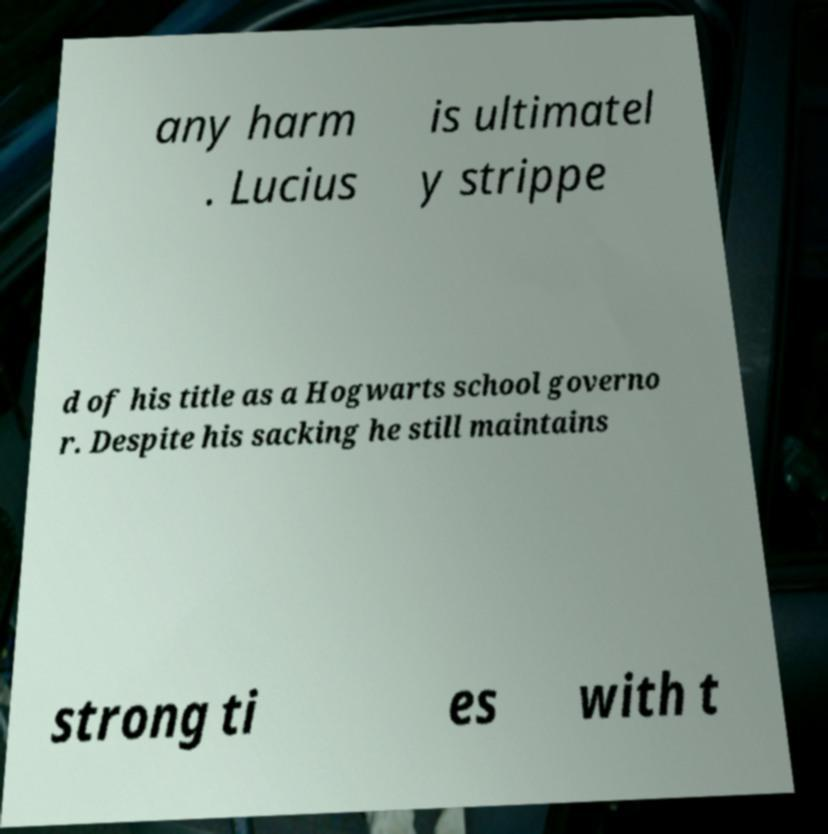Could you extract and type out the text from this image? any harm . Lucius is ultimatel y strippe d of his title as a Hogwarts school governo r. Despite his sacking he still maintains strong ti es with t 